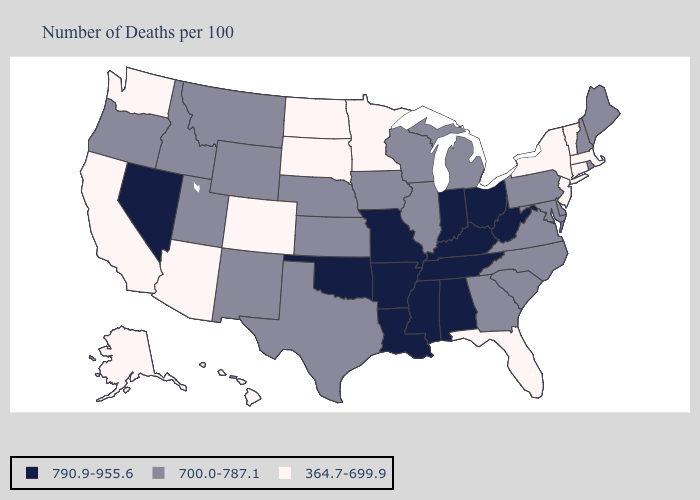Does Montana have the highest value in the USA?
Write a very short answer. No. Among the states that border Wisconsin , which have the lowest value?
Answer briefly. Minnesota. Does South Carolina have the same value as Oregon?
Write a very short answer. Yes. Does New Hampshire have a lower value than Arizona?
Short answer required. No. What is the highest value in the MidWest ?
Be succinct. 790.9-955.6. What is the value of Texas?
Write a very short answer. 700.0-787.1. What is the highest value in the USA?
Quick response, please. 790.9-955.6. Does the map have missing data?
Short answer required. No. Which states hav the highest value in the South?
Quick response, please. Alabama, Arkansas, Kentucky, Louisiana, Mississippi, Oklahoma, Tennessee, West Virginia. Is the legend a continuous bar?
Answer briefly. No. Which states have the highest value in the USA?
Short answer required. Alabama, Arkansas, Indiana, Kentucky, Louisiana, Mississippi, Missouri, Nevada, Ohio, Oklahoma, Tennessee, West Virginia. What is the value of Indiana?
Answer briefly. 790.9-955.6. Among the states that border Pennsylvania , which have the highest value?
Answer briefly. Ohio, West Virginia. Does North Dakota have the highest value in the MidWest?
Be succinct. No. Which states have the lowest value in the MidWest?
Short answer required. Minnesota, North Dakota, South Dakota. 